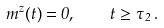<formula> <loc_0><loc_0><loc_500><loc_500>m ^ { z } ( t ) = 0 , \quad t \geq \tau _ { 2 } \, .</formula> 